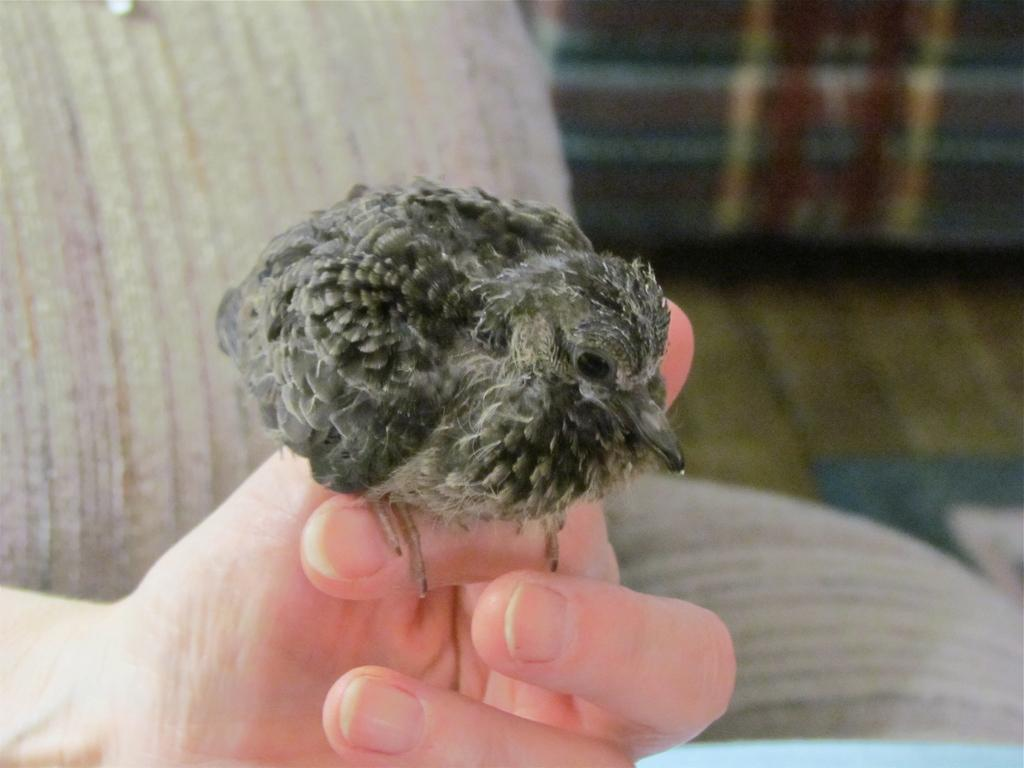What type of animal can be seen in the image? There is a bird in the image. What is the bird doing in the image? The bird is sitting on a person's fingers. What can be seen in the background of the image? There is a sofa in the background of the image. What is visible at the bottom of the image? There is a floor visible at the bottom of the image. What is the development status of the bird in the image? There is no information about the bird's development status in the image. Is there a fight happening between the bird and the person in the image? No, there is no fight depicted in the image; the bird is simply sitting on the person's fingers. 